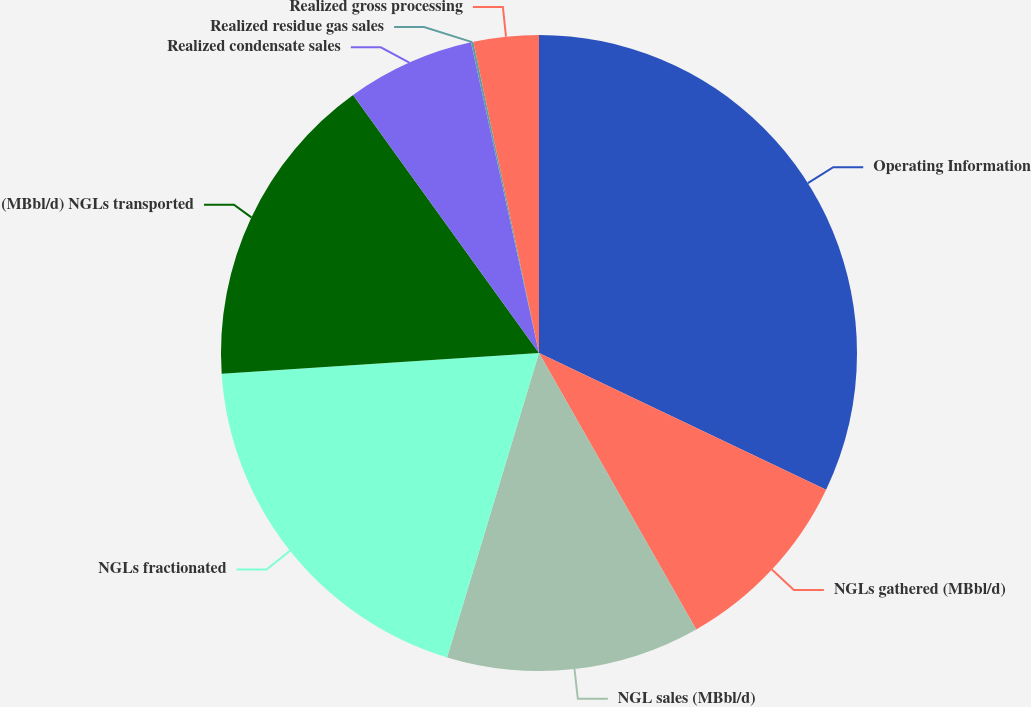Convert chart. <chart><loc_0><loc_0><loc_500><loc_500><pie_chart><fcel>Operating Information<fcel>NGLs gathered (MBbl/d)<fcel>NGL sales (MBbl/d)<fcel>NGLs fractionated<fcel>(MBbl/d) NGLs transported<fcel>Realized condensate sales<fcel>Realized residue gas sales<fcel>Realized gross processing<nl><fcel>32.07%<fcel>9.7%<fcel>12.9%<fcel>19.29%<fcel>16.1%<fcel>6.51%<fcel>0.12%<fcel>3.31%<nl></chart> 